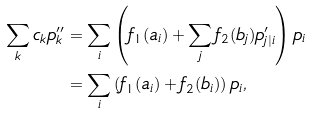<formula> <loc_0><loc_0><loc_500><loc_500>\sum _ { k } c _ { k } p _ { k } ^ { \prime \prime } & = \sum _ { i } \left ( f _ { 1 } ( a _ { i } ) + \sum _ { j } f _ { 2 } ( b _ { j } ) p ^ { \prime } _ { j | i } \right ) p _ { i } \\ & = \sum _ { i } \left ( f _ { 1 } ( a _ { i } ) + f _ { 2 } ( b _ { i } ) \right ) p _ { i } ,</formula> 